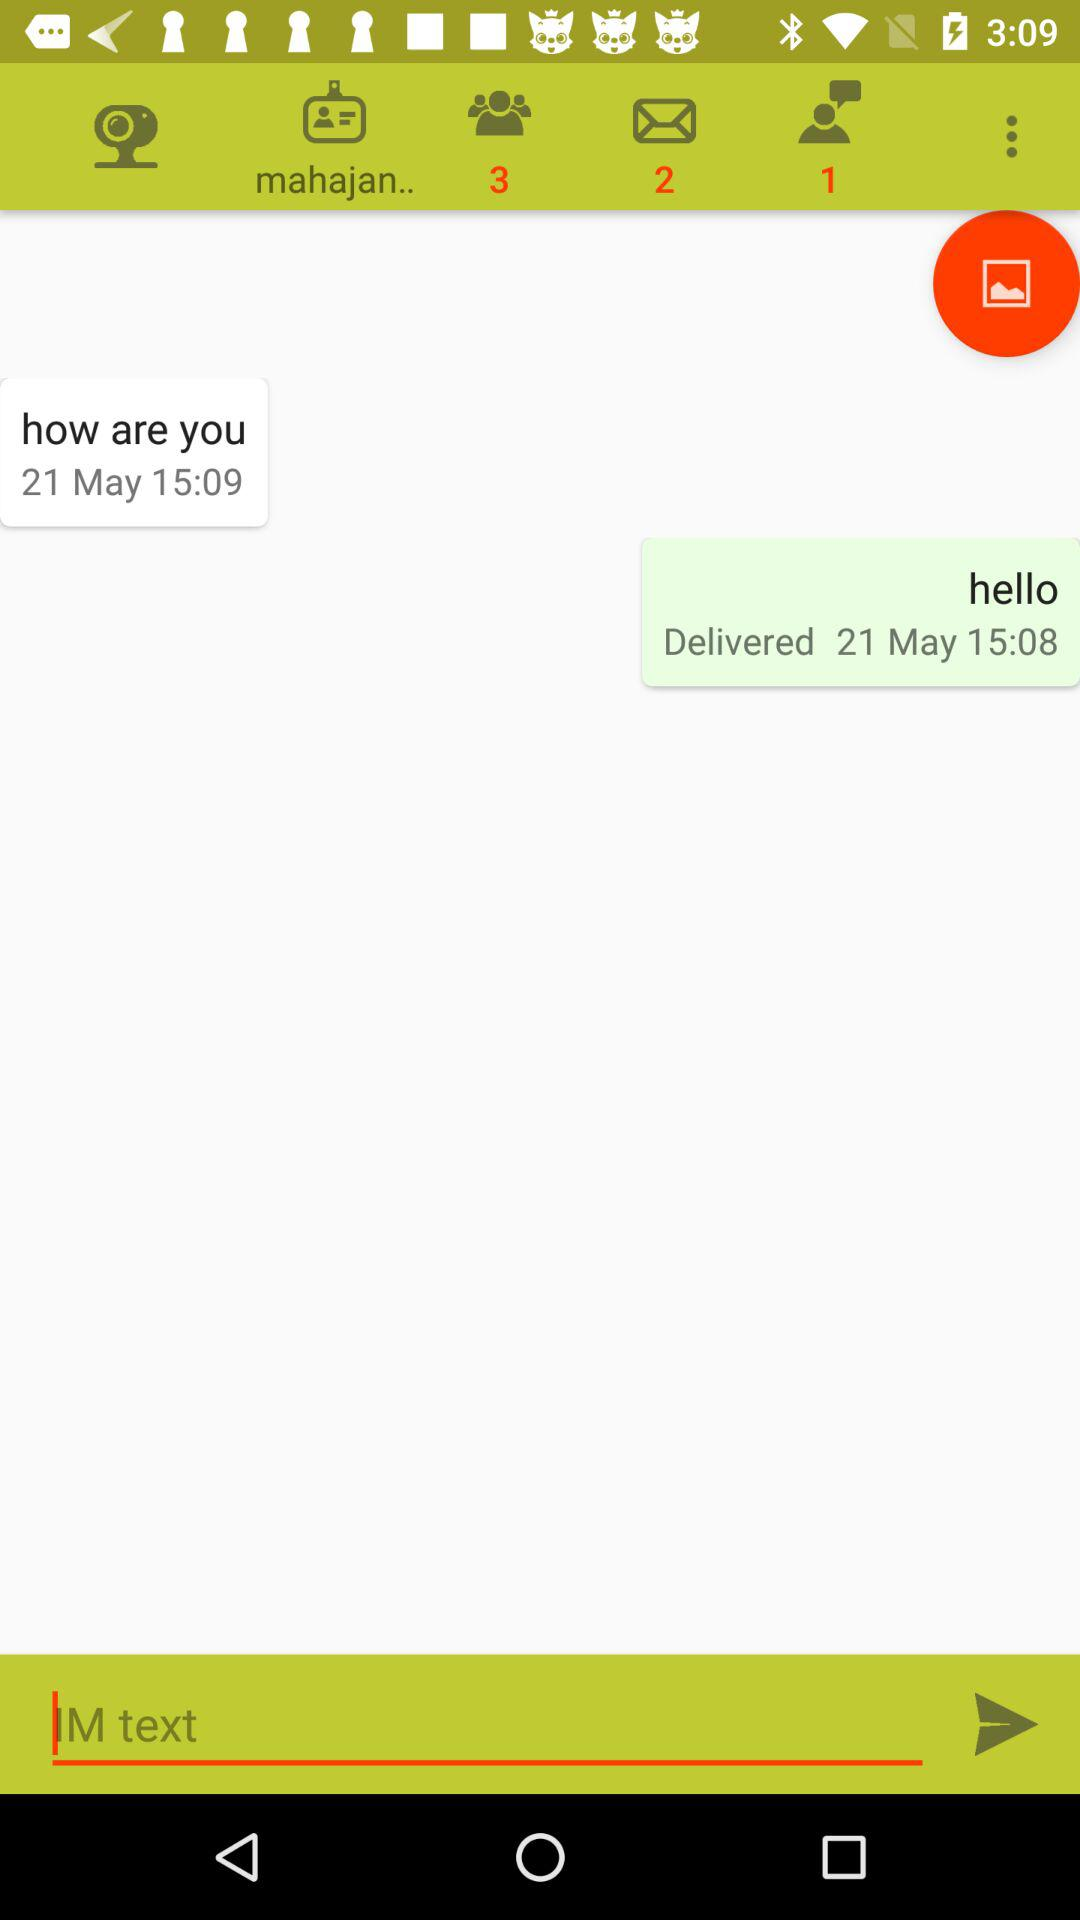What is the date? The date is May 21. 